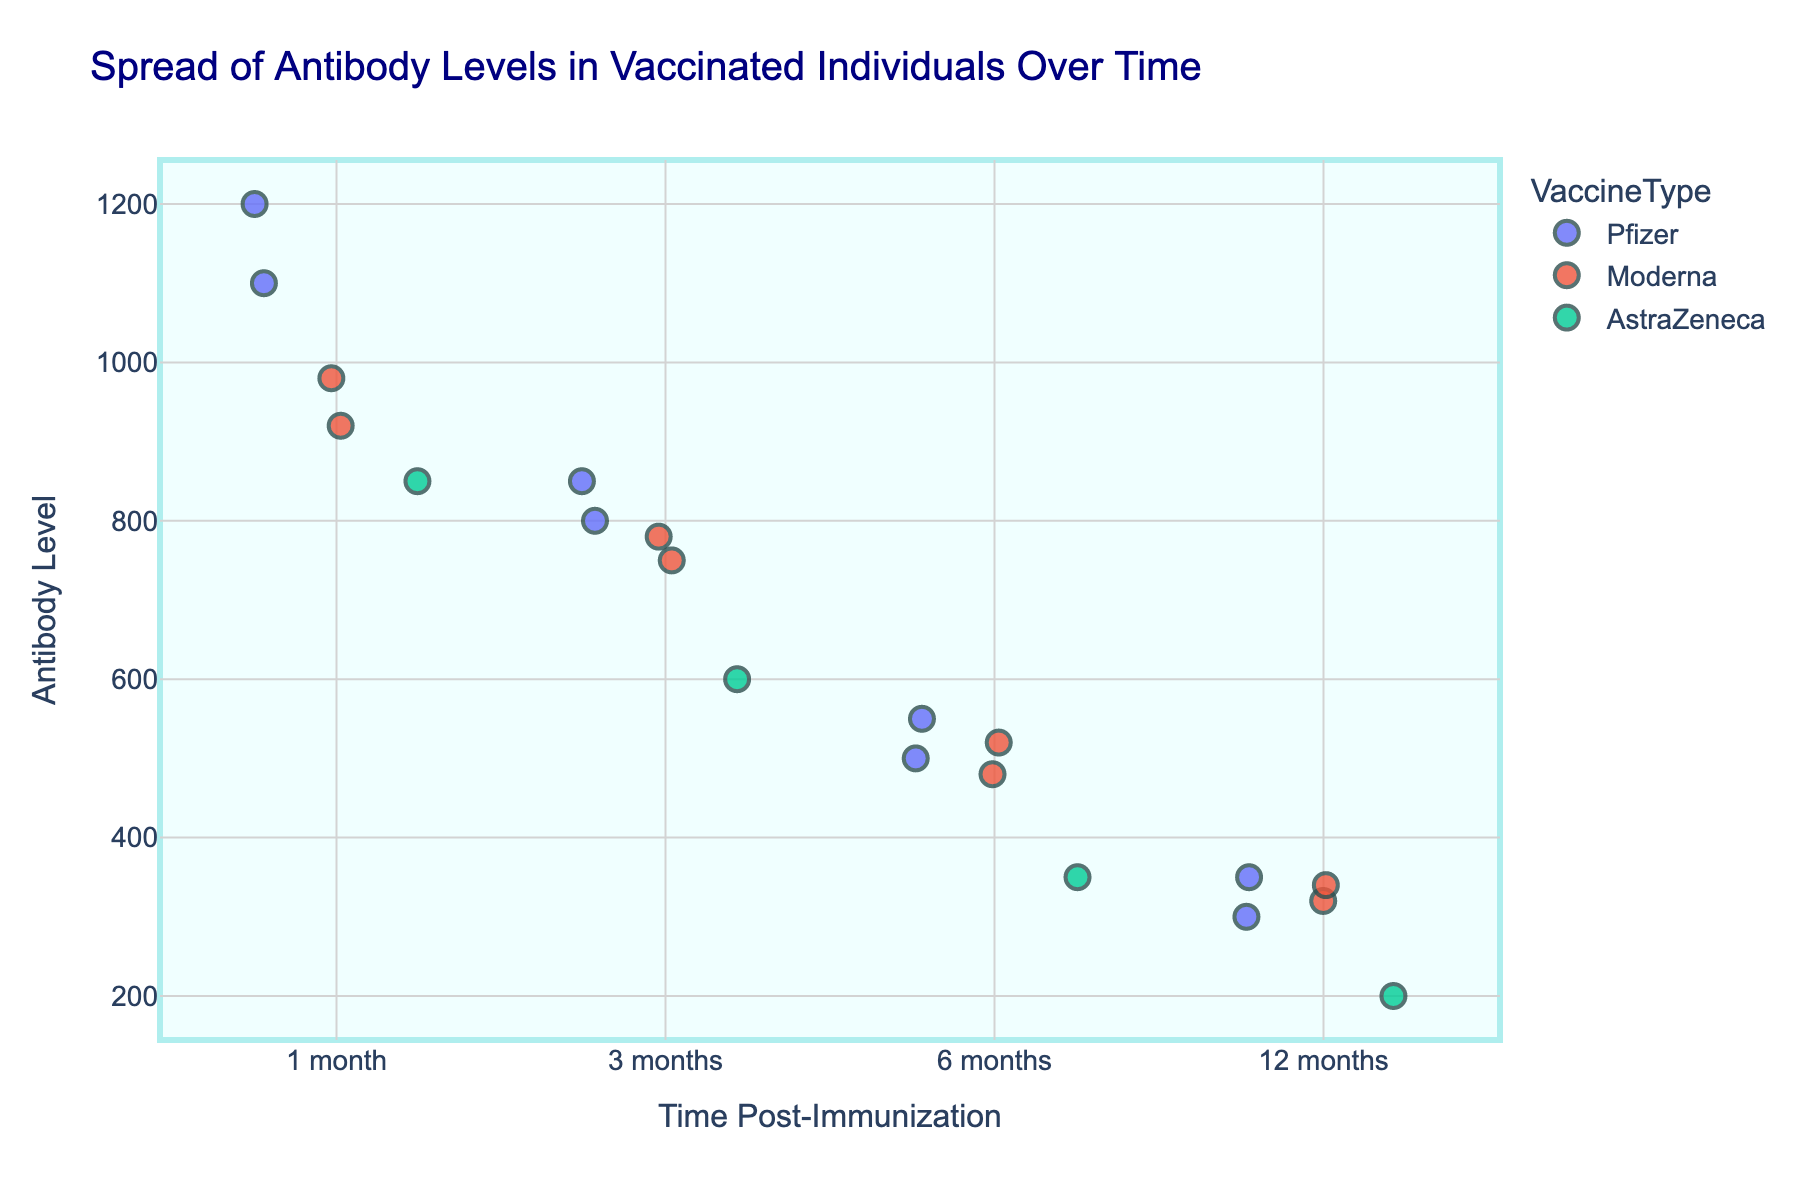What's the title of the plot? The title is typically positioned at the top of a plot and is usually one of the first elements noticed. It summarizes what the plot is about.
Answer: Spread of Antibody Levels in Vaccinated Individuals Over Time What are the labels for the x-axis and y-axis? The labels for the axes describe what the data points represent in the plot. The x-axis label is usually at the bottom and the y-axis label is on the side.
Answer: Time Post-Immunization (x-axis), Antibody Level (y-axis) How many data points are there for each time interval? To find the number of data points for each time interval, count the number of individual markers corresponding to each labeled time (e.g., 1 month, 3 months, etc.).
Answer: 5 data points for each time interval Which vaccine type shows the highest antibody level at 1 month? Look at the data points at the 1-month interval and identify the colored marker (linked to the VaccineType) with the highest y-coordinate (Antibody Level).
Answer: Pfizer How do antibody levels change over time for Pfizer? Observe the distribution of Pfizer's data points across different time intervals on the x-axis and note the trend in their y-coordinate values (Antibody Level). They generally decrease.
Answer: They generally decrease At 6 months, which vaccine type has the lowest antibody level and what is it? Find the 6-month interval, locate the data point with the lowest y-coordinate (Antibody Level), and identify its VaccineType by its color.
Answer: AstraZeneca, 350 What is the average antibody level for Moderna at 12 months? Identify the Antibody Level values for Moderna at 12 months and compute their arithmetic mean. Specifically, sum the antibody levels and divide by the number of data points (320 + 340) / 2.
Answer: 330 Compare the antibody levels between 1 month and 12 months for AstraZeneca. What can you conclude? Compare the distribution and specific values of AstraZeneca's data points at 1 month and 12 months. This involves subtracting the 12-month levels from the 1-month levels to get a general sense of the decline.
Answer: There is a significant decrease from around 850 to around 200 Which vaccine types have overlapping antibody levels at the 3-month mark? Look at the antibody level intervals at 3 months and check for overlapping y-coordinates (levels) among different colored markers (VaccineTypes).
Answer: Pfizer, Moderna What is the range of antibody levels observed at 12 months? Determine the difference between the highest and the lowest antibody levels at the 12-month interval from the y-axis values.
Answer: 200 to 350 